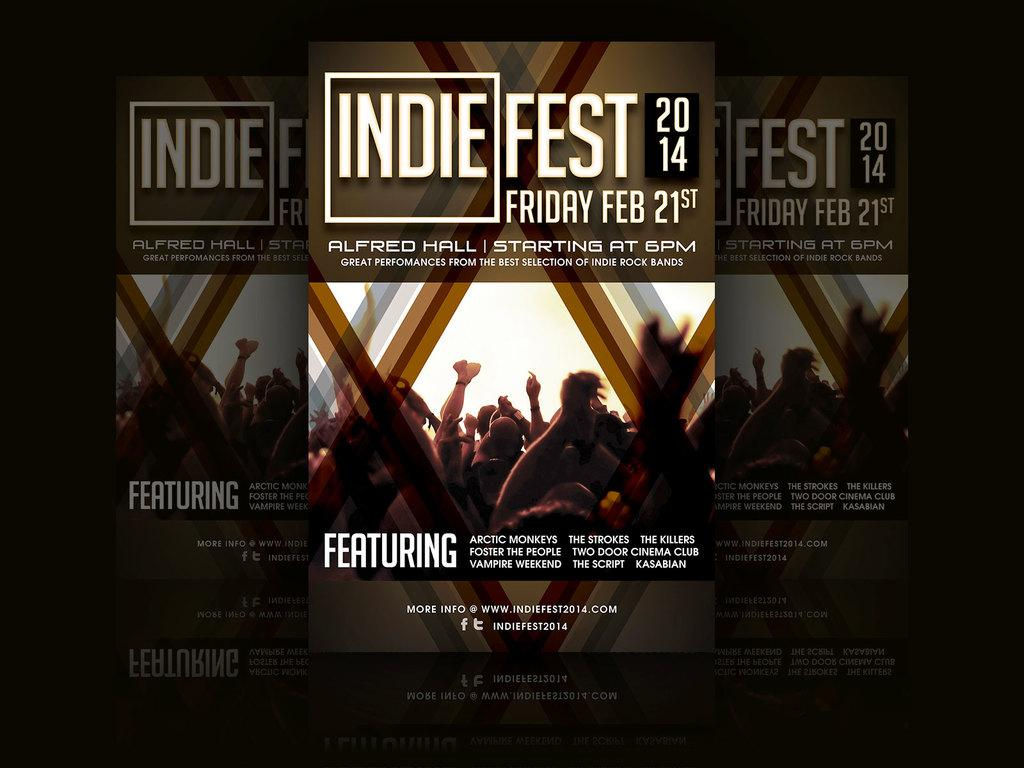Provide a one-sentence caption for the provided image. A poster advertises a festival in February 2014. 